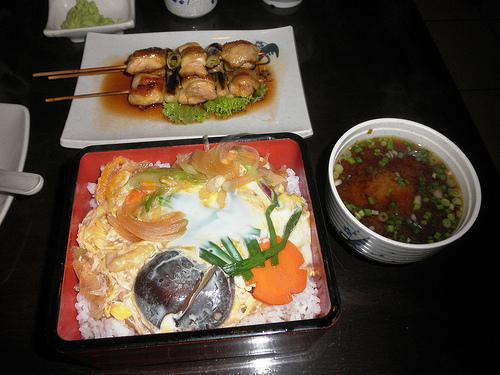Question: what is on top of the soup?
Choices:
A. Cheese.
B. Spices.
C. Green onions.
D. Croutons.
Answer with the letter. Answer: C Question: what is in the bowl?
Choices:
A. Salad.
B. Soup.
C. Pudding.
D. Ice cream.
Answer with the letter. Answer: B Question: how many carrot slices?
Choices:
A. 1.
B. 2.
C. 3.
D. 4.
Answer with the letter. Answer: A Question: what color is the wasabi?
Choices:
A. Brown.
B. No other plausible answers.
C. Green.
D. Nothing else plausible.
Answer with the letter. Answer: C 